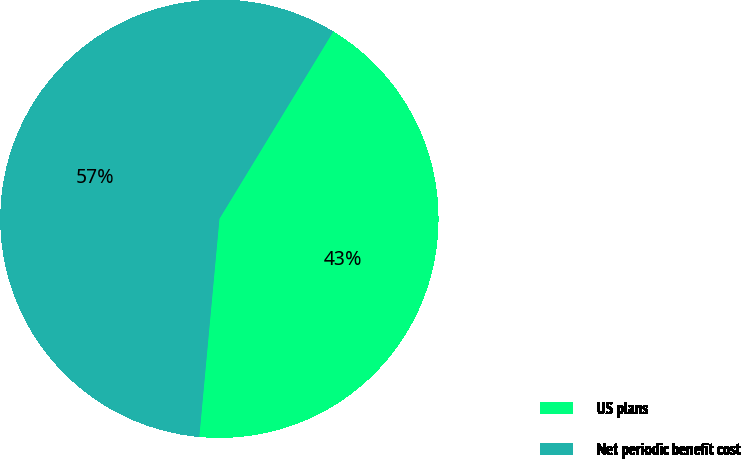Convert chart. <chart><loc_0><loc_0><loc_500><loc_500><pie_chart><fcel>US plans<fcel>Net periodic benefit cost<nl><fcel>42.77%<fcel>57.23%<nl></chart> 